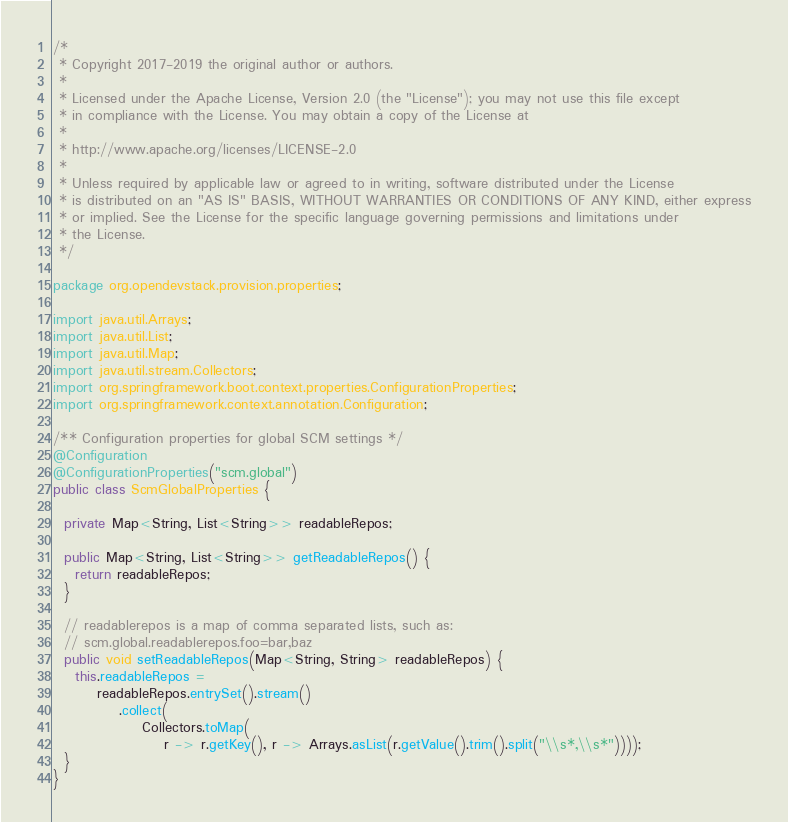Convert code to text. <code><loc_0><loc_0><loc_500><loc_500><_Java_>/*
 * Copyright 2017-2019 the original author or authors.
 *
 * Licensed under the Apache License, Version 2.0 (the "License"); you may not use this file except
 * in compliance with the License. You may obtain a copy of the License at
 *
 * http://www.apache.org/licenses/LICENSE-2.0
 *
 * Unless required by applicable law or agreed to in writing, software distributed under the License
 * is distributed on an "AS IS" BASIS, WITHOUT WARRANTIES OR CONDITIONS OF ANY KIND, either express
 * or implied. See the License for the specific language governing permissions and limitations under
 * the License.
 */

package org.opendevstack.provision.properties;

import java.util.Arrays;
import java.util.List;
import java.util.Map;
import java.util.stream.Collectors;
import org.springframework.boot.context.properties.ConfigurationProperties;
import org.springframework.context.annotation.Configuration;

/** Configuration properties for global SCM settings */
@Configuration
@ConfigurationProperties("scm.global")
public class ScmGlobalProperties {

  private Map<String, List<String>> readableRepos;

  public Map<String, List<String>> getReadableRepos() {
    return readableRepos;
  }

  // readablerepos is a map of comma separated lists, such as:
  // scm.global.readablerepos.foo=bar,baz
  public void setReadableRepos(Map<String, String> readableRepos) {
    this.readableRepos =
        readableRepos.entrySet().stream()
            .collect(
                Collectors.toMap(
                    r -> r.getKey(), r -> Arrays.asList(r.getValue().trim().split("\\s*,\\s*"))));
  }
}
</code> 